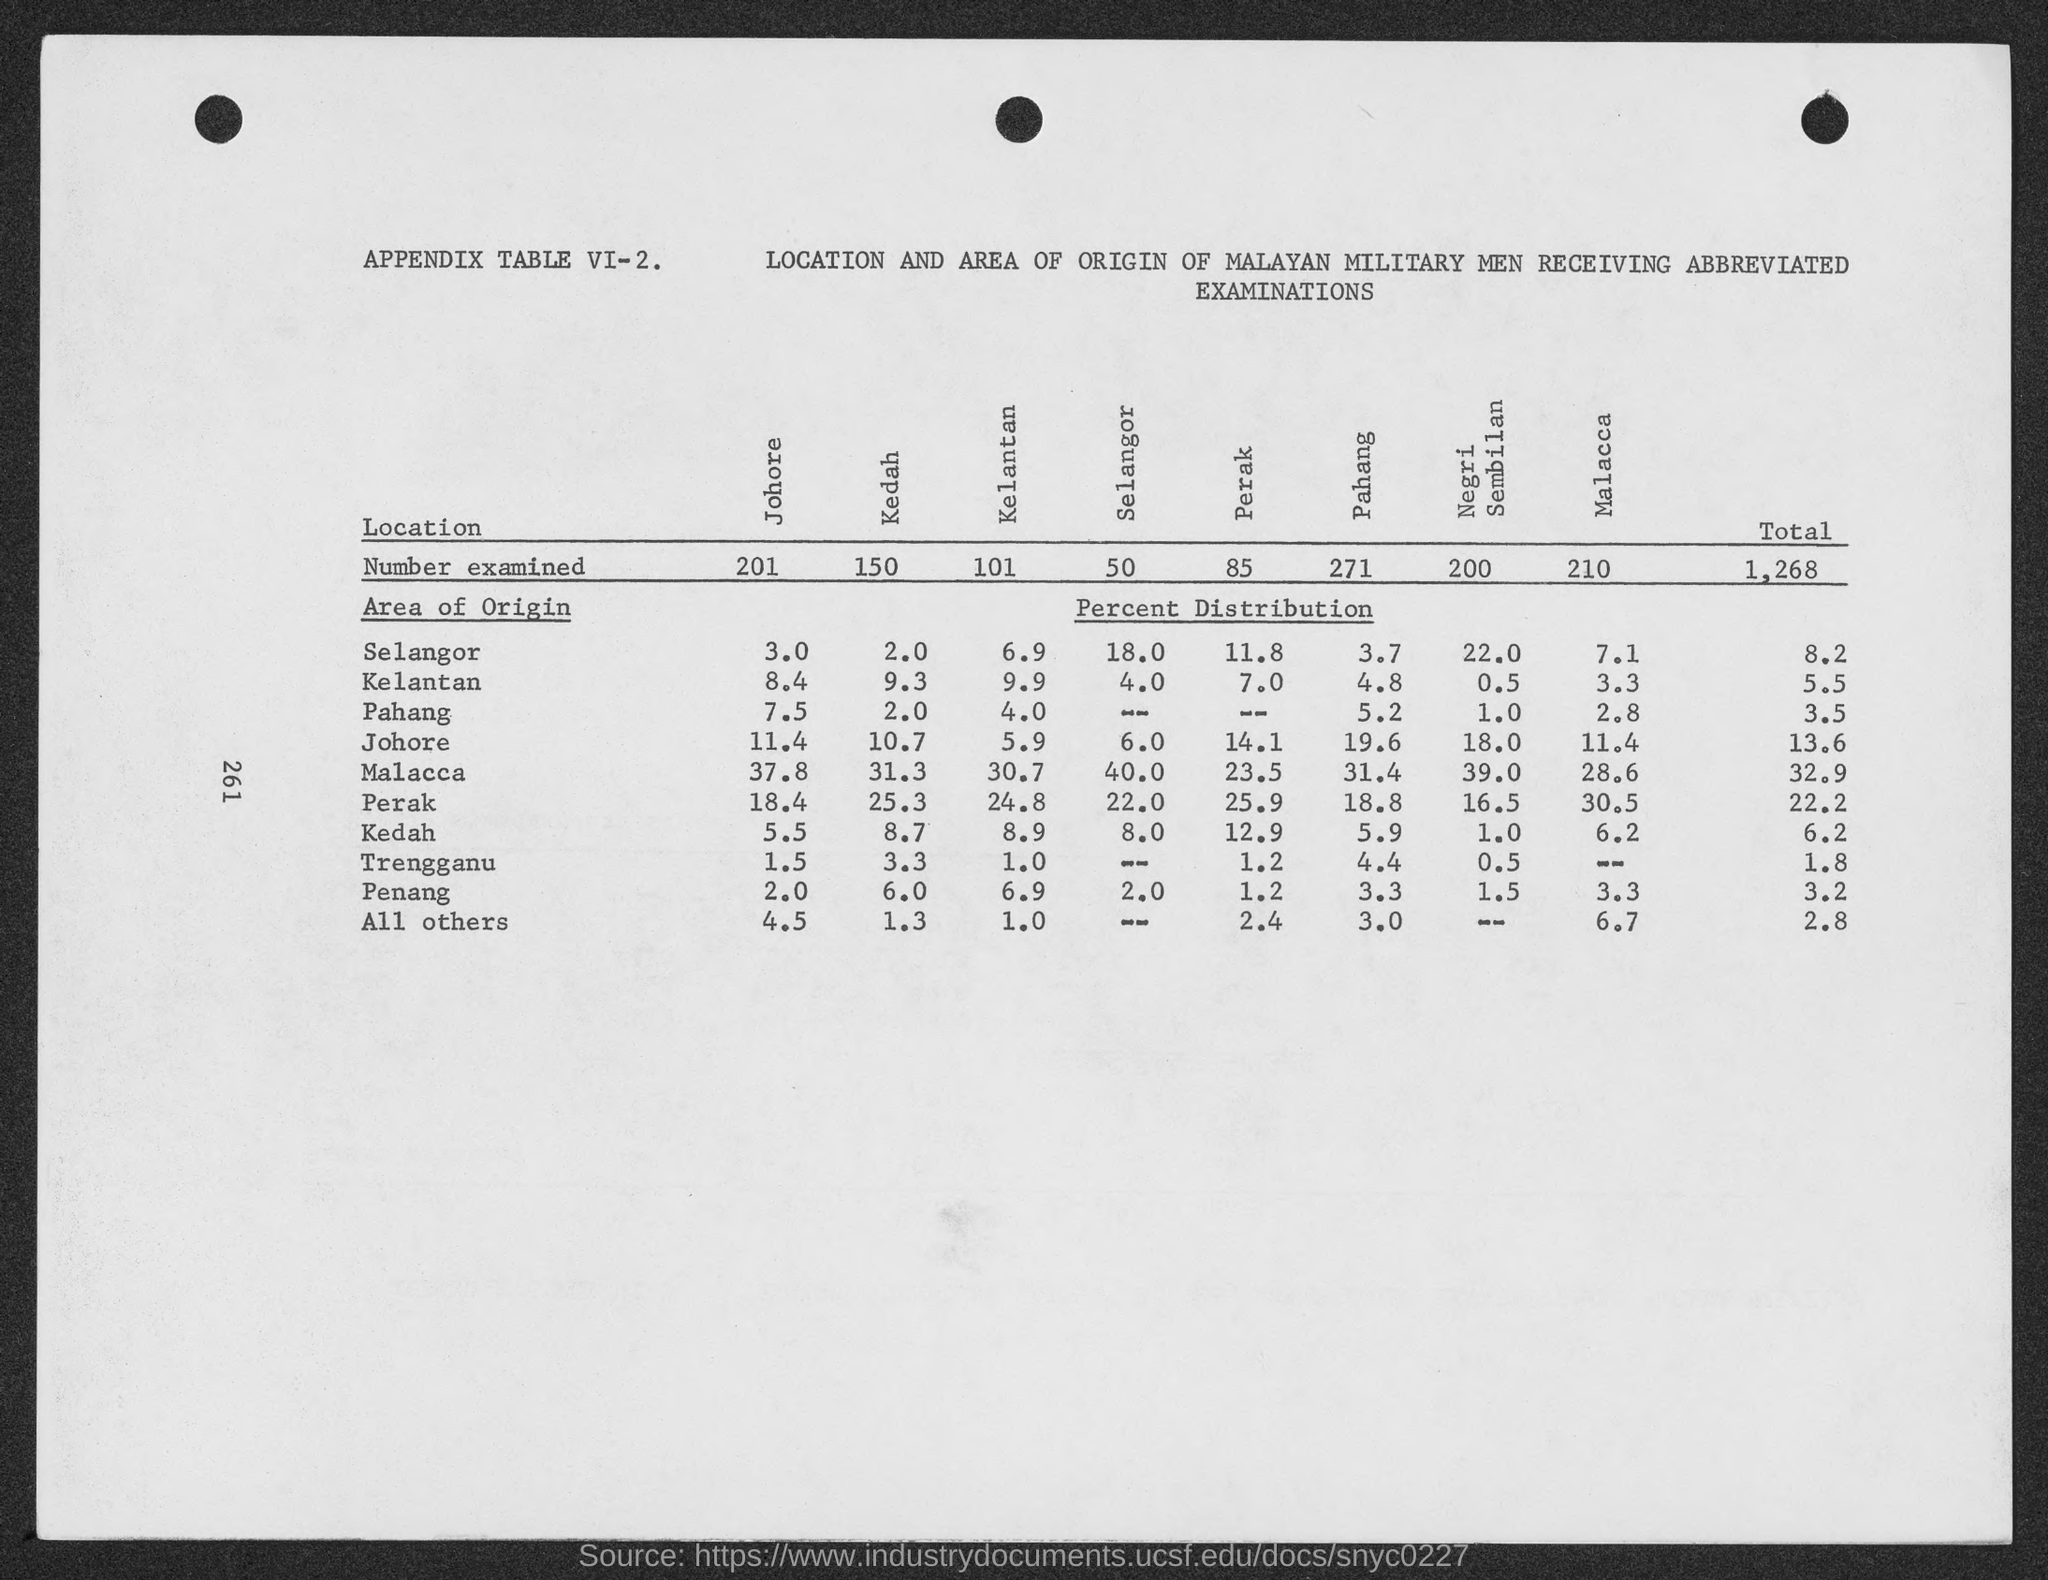Specify some key components in this picture. In total, 1,268 items were examined. The number of examined samples from Kedah is 150. 